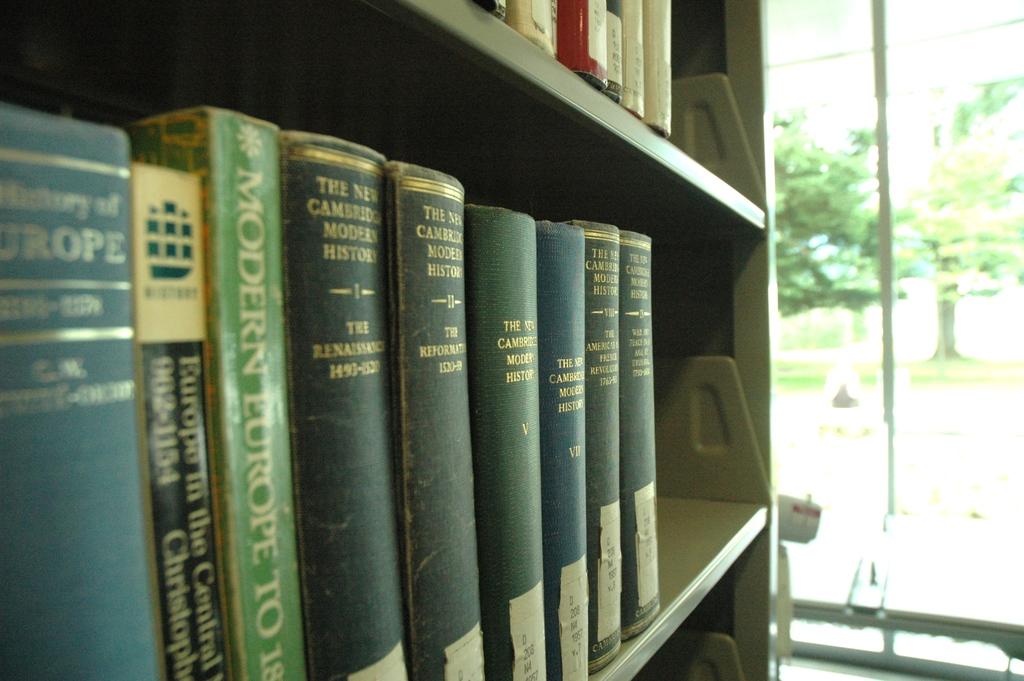Is there a book on the renaissance here?
Keep it short and to the point. Yes. 